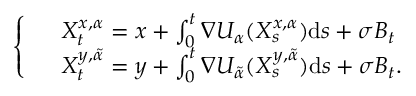Convert formula to latex. <formula><loc_0><loc_0><loc_500><loc_500>\left \{ \begin{array} { l l } & { X _ { t } ^ { x , \alpha } = x + \int _ { 0 } ^ { t } \nabla U _ { \alpha } ( X _ { s } ^ { x , \alpha } ) d s + \sigma B _ { t } } \\ & { X _ { t } ^ { y , \tilde { \alpha } } = y + \int _ { 0 } ^ { t } \nabla U _ { \tilde { \alpha } } ( X _ { s } ^ { y , \tilde { \alpha } } ) d s + \sigma B _ { t } . } \end{array}</formula> 